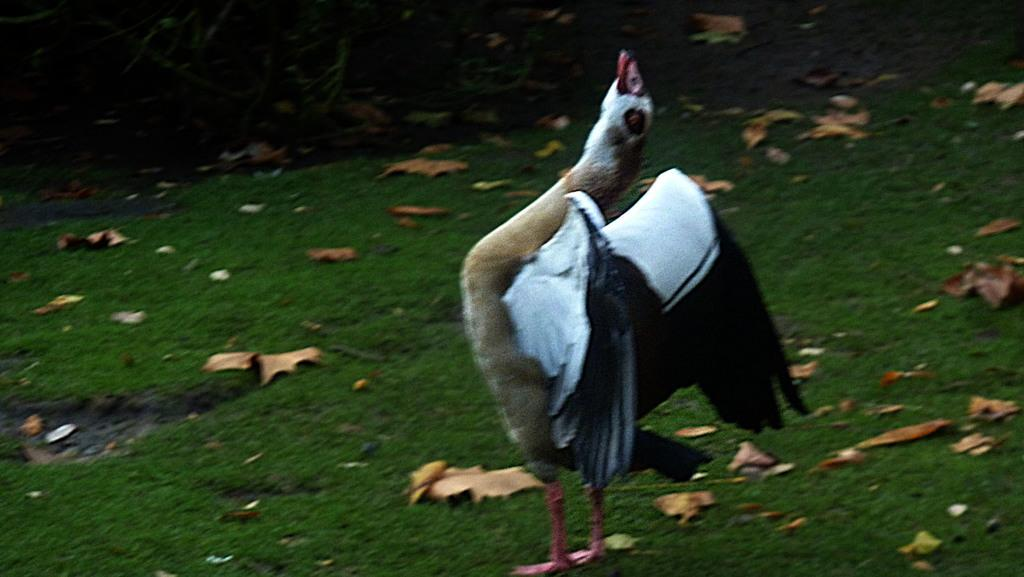What is the main subject in the center of the image? There is a bird in the center of the image. What type of vegetation is present in the image? There is grass in the image. Are there any additional elements on the grass? Yes, there are dry leaves on the grass. What type of jewel is the bird holding in its beak in the image? There is no jewel present in the image; the bird is not holding anything in its beak. 